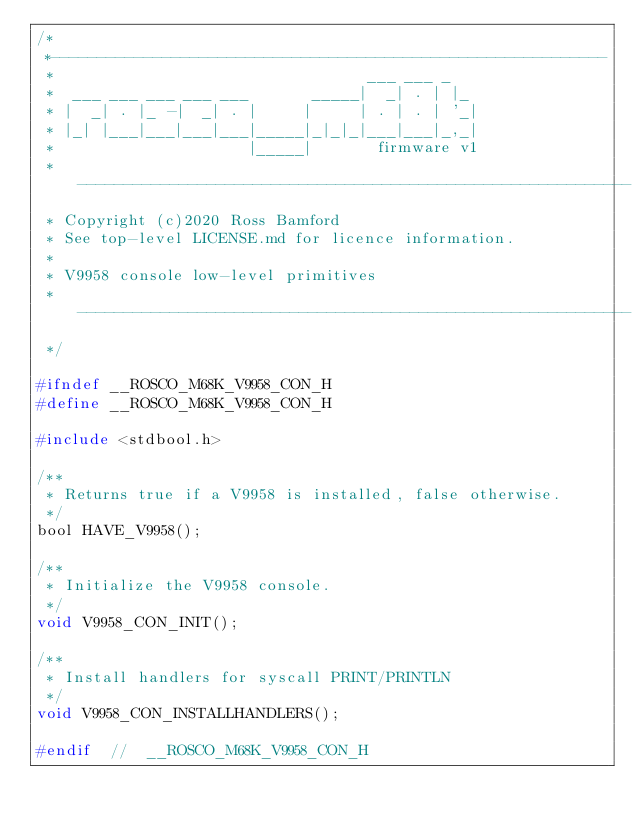Convert code to text. <code><loc_0><loc_0><loc_500><loc_500><_C_>/*
 *------------------------------------------------------------
 *                                  ___ ___ _
 *  ___ ___ ___ ___ ___       _____|  _| . | |_
 * |  _| . |_ -|  _| . |     |     | . | . | '_|
 * |_| |___|___|___|___|_____|_|_|_|___|___|_,_|
 *                     |_____|       firmware v1
 * ------------------------------------------------------------
 * Copyright (c)2020 Ross Bamford
 * See top-level LICENSE.md for licence information.
 *
 * V9958 console low-level primitives
 * ------------------------------------------------------------
 */

#ifndef __ROSCO_M68K_V9958_CON_H
#define __ROSCO_M68K_V9958_CON_H

#include <stdbool.h>

/**
 * Returns true if a V9958 is installed, false otherwise.
 */
bool HAVE_V9958();

/**
 * Initialize the V9958 console.
 */
void V9958_CON_INIT();

/**
 * Install handlers for syscall PRINT/PRINTLN
 */
void V9958_CON_INSTALLHANDLERS();

#endif  //  __ROSCO_M68K_V9958_CON_H
</code> 